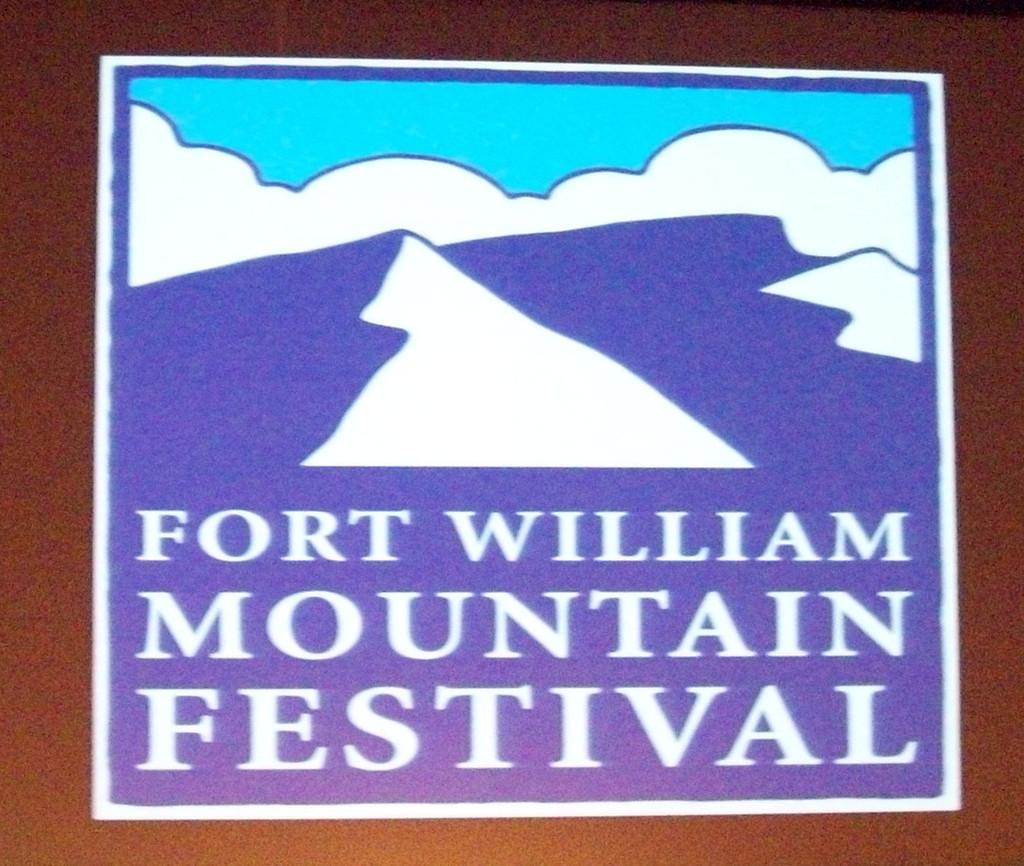Provide a one-sentence caption for the provided image. A sign for the Fort William Mountain Festival features mountains. 